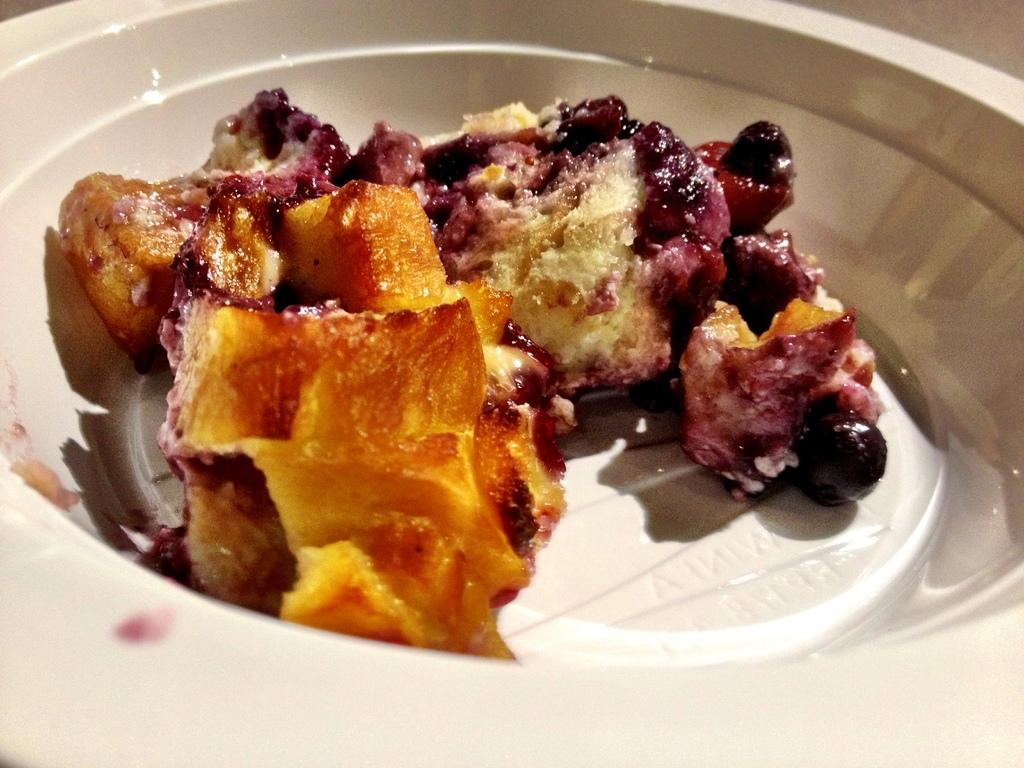What type of food is served in the bowl in the image? There is dessert served in a bowl in the image. How many houses are visible in the image? There are no houses visible in the image; it only shows dessert served in a bowl. 